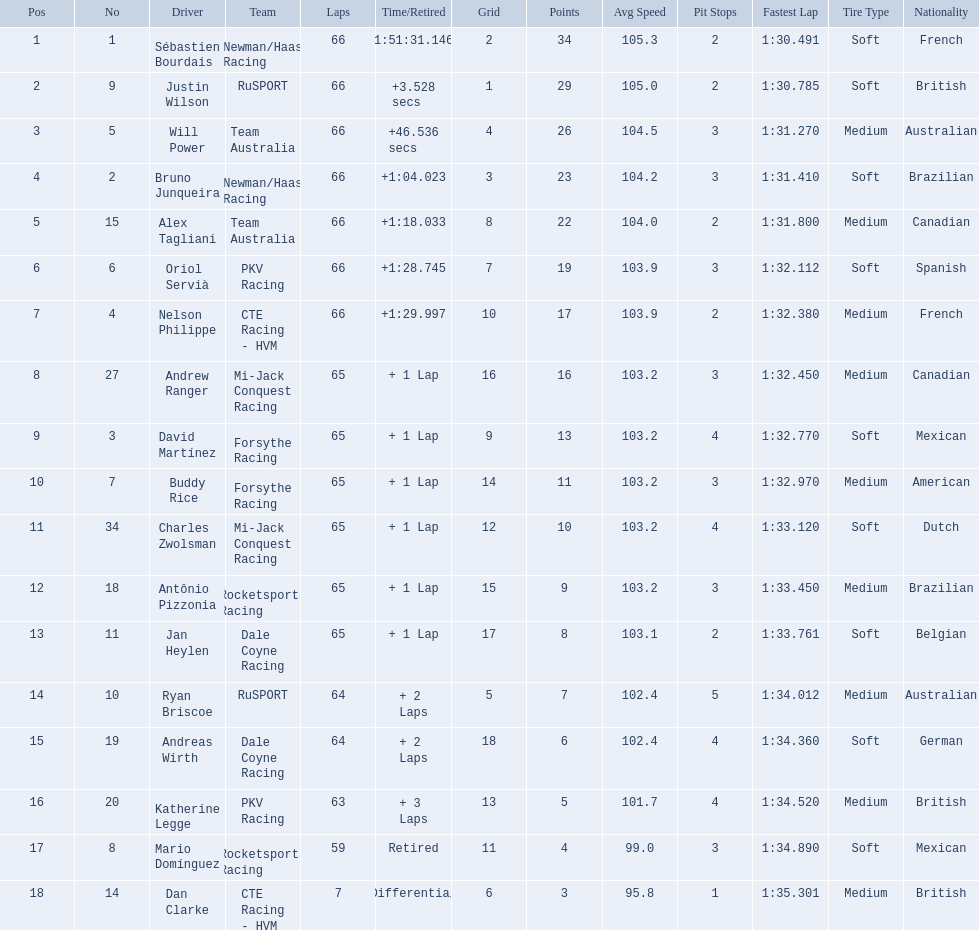What drivers started in the top 10? Sébastien Bourdais, Justin Wilson, Will Power, Bruno Junqueira, Alex Tagliani, Oriol Servià, Nelson Philippe, Ryan Briscoe, Dan Clarke. Which of those drivers completed all 66 laps? Sébastien Bourdais, Justin Wilson, Will Power, Bruno Junqueira, Alex Tagliani, Oriol Servià, Nelson Philippe. Whom of these did not drive for team australia? Sébastien Bourdais, Justin Wilson, Bruno Junqueira, Oriol Servià, Nelson Philippe. Which of these drivers finished more then a minuet after the winner? Bruno Junqueira, Oriol Servià, Nelson Philippe. Which of these drivers had the highest car number? Oriol Servià. 